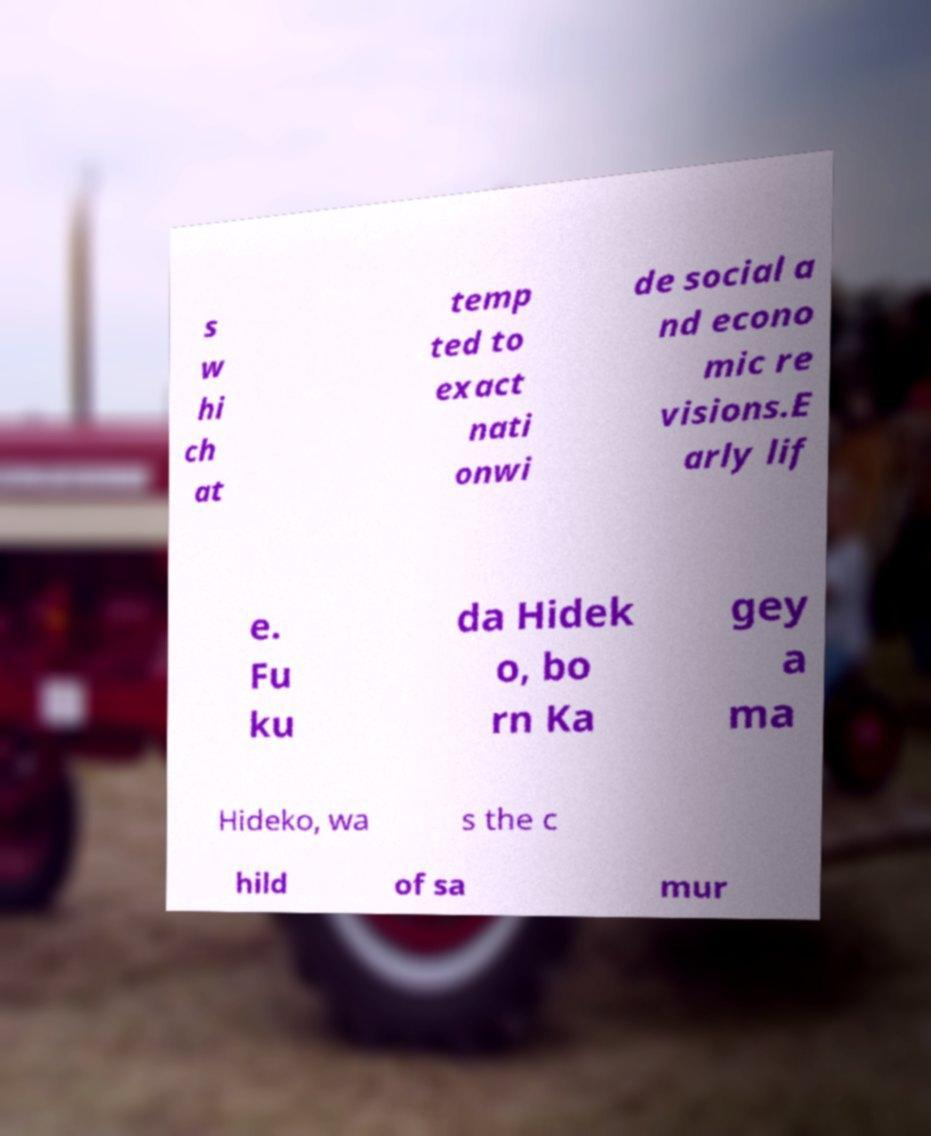Could you assist in decoding the text presented in this image and type it out clearly? s w hi ch at temp ted to exact nati onwi de social a nd econo mic re visions.E arly lif e. Fu ku da Hidek o, bo rn Ka gey a ma Hideko, wa s the c hild of sa mur 